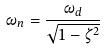<formula> <loc_0><loc_0><loc_500><loc_500>\omega _ { n } = \frac { \omega _ { d } } { \sqrt { 1 - \zeta ^ { 2 } } }</formula> 